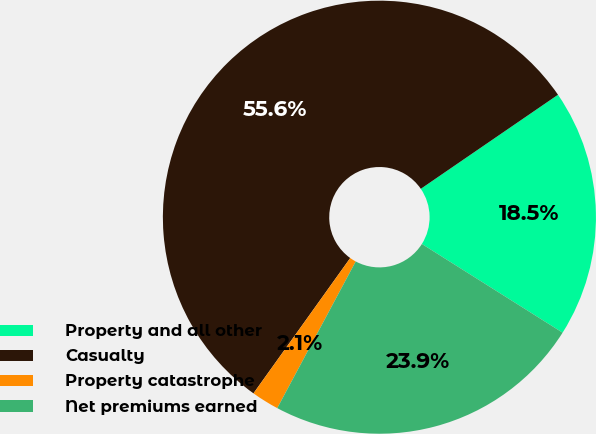<chart> <loc_0><loc_0><loc_500><loc_500><pie_chart><fcel>Property and all other<fcel>Casualty<fcel>Property catastrophe<fcel>Net premiums earned<nl><fcel>18.52%<fcel>55.56%<fcel>2.06%<fcel>23.87%<nl></chart> 